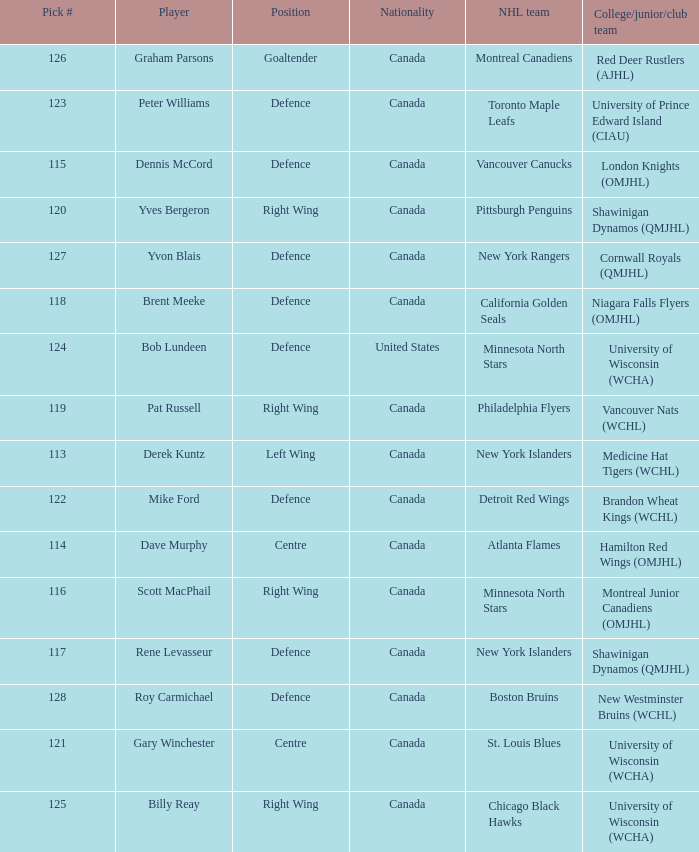Name the position for pick number 128 Defence. 